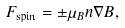Convert formula to latex. <formula><loc_0><loc_0><loc_500><loc_500>F _ { \text {spin} } = \pm \mu _ { B } n \nabla B ,</formula> 